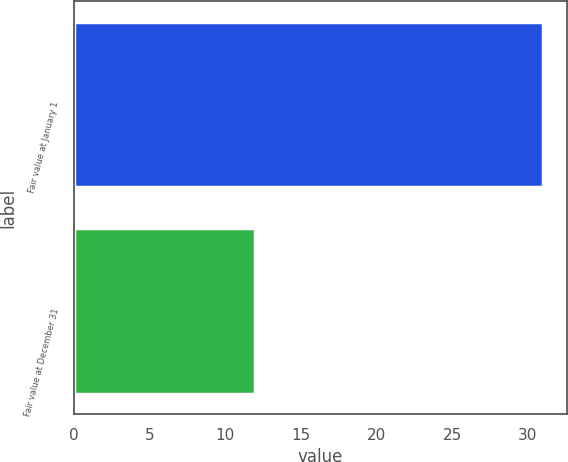<chart> <loc_0><loc_0><loc_500><loc_500><bar_chart><fcel>Fair value at January 1<fcel>Fair value at December 31<nl><fcel>31<fcel>12<nl></chart> 